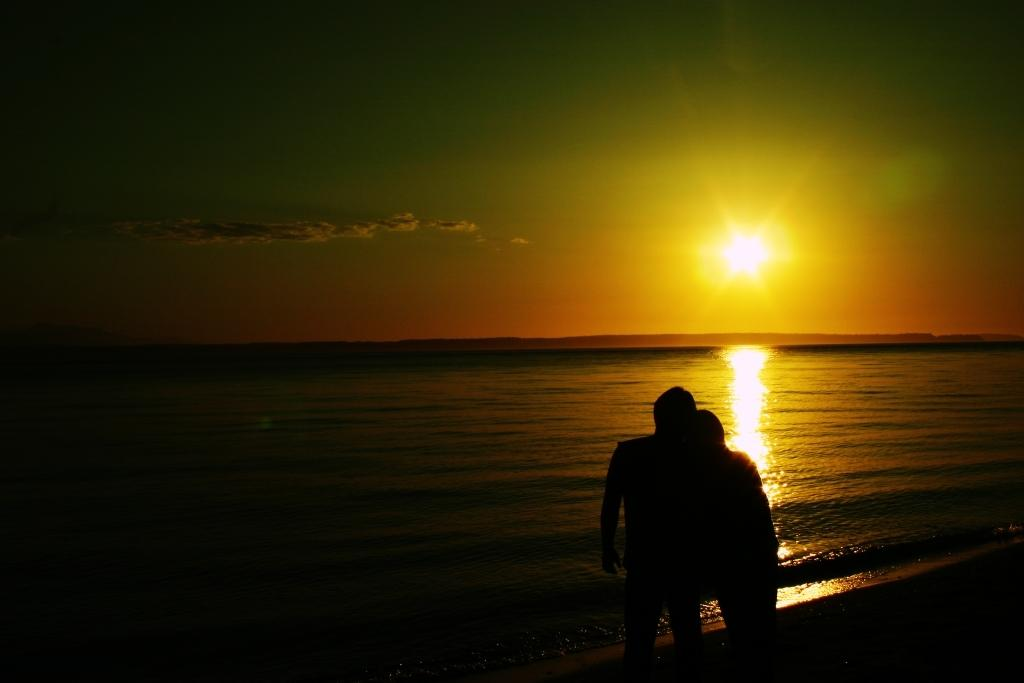How many people are in the image? There are two persons in the image. Where are the persons located in the image? The persons are standing at the sea shore. What are the persons doing in the image? The persons are hugging each other. What can be seen in the background of the image? There is water and a sunset visible in the background of the image. What is the color of the sky in the image? The sky has an orange color. How many sheep are present in the image? There are no sheep present in the image. Are there any slaves depicted in the image? There is no mention or depiction of slavery in the image. 